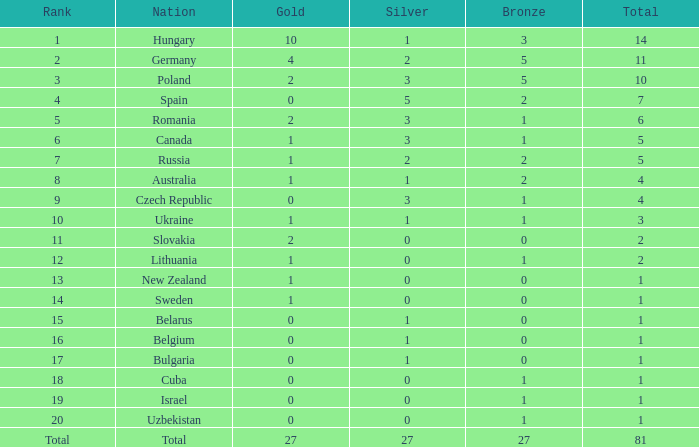Parse the table in full. {'header': ['Rank', 'Nation', 'Gold', 'Silver', 'Bronze', 'Total'], 'rows': [['1', 'Hungary', '10', '1', '3', '14'], ['2', 'Germany', '4', '2', '5', '11'], ['3', 'Poland', '2', '3', '5', '10'], ['4', 'Spain', '0', '5', '2', '7'], ['5', 'Romania', '2', '3', '1', '6'], ['6', 'Canada', '1', '3', '1', '5'], ['7', 'Russia', '1', '2', '2', '5'], ['8', 'Australia', '1', '1', '2', '4'], ['9', 'Czech Republic', '0', '3', '1', '4'], ['10', 'Ukraine', '1', '1', '1', '3'], ['11', 'Slovakia', '2', '0', '0', '2'], ['12', 'Lithuania', '1', '0', '1', '2'], ['13', 'New Zealand', '1', '0', '0', '1'], ['14', 'Sweden', '1', '0', '0', '1'], ['15', 'Belarus', '0', '1', '0', '1'], ['16', 'Belgium', '0', '1', '0', '1'], ['17', 'Bulgaria', '0', '1', '0', '1'], ['18', 'Cuba', '0', '0', '1', '1'], ['19', 'Israel', '0', '0', '1', '1'], ['20', 'Uzbekistan', '0', '0', '1', '1'], ['Total', 'Total', '27', '27', '27', '81']]} Which Bronze has a Gold of 2, and a Nation of slovakia, and a Total larger than 2? None. 